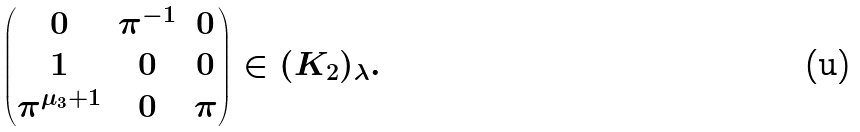<formula> <loc_0><loc_0><loc_500><loc_500>\begin{pmatrix} 0 & \pi ^ { - 1 } & 0 \\ 1 & 0 & 0 \\ \pi ^ { \mu _ { 3 } + 1 } & 0 & \pi \end{pmatrix} \in ( K _ { 2 } ) _ { \lambda } .</formula> 